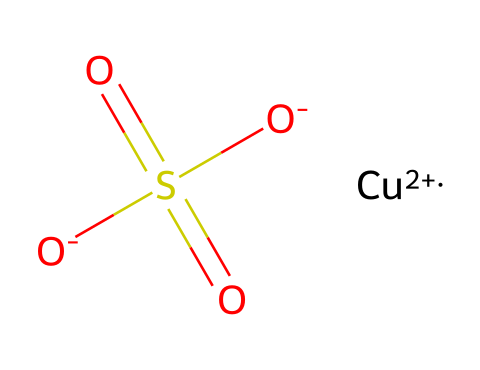What is the metal cation present in this solution? The chemical structure shows a copper ion indicated by [Cu+2], which is the metal cation present.
Answer: copper How many oxygen atoms are present in this chemical? By analyzing the structure, we see there are three oxygen atoms: two from the sulfate group (O-) and one more singular O.
Answer: three What type of compound is indicated by the sulfate group in this structure? The presence of the sulfate group (S(=O)(=O)[O-]) classifies this compound as a sulfide and specifically, a sulfate ion.
Answer: sulfate What is the oxidation state of copper in this compound? The SMILES representation shows [Cu+2], indicating that copper has an oxidation state of +2 in this solution.
Answer: +2 Does this chemical represent a stable or unstable non-Newtonian fluid? The presence of a metal ion and sulfate suggests it interacts in a way that could create a stable colloidal suspension, typical of non-Newtonian fluids.
Answer: stable What is the anionic component of this patina solution? The sulfate part (O-]S(=O)(=O)[O-) serves as the anion in this chemical.
Answer: sulfate 